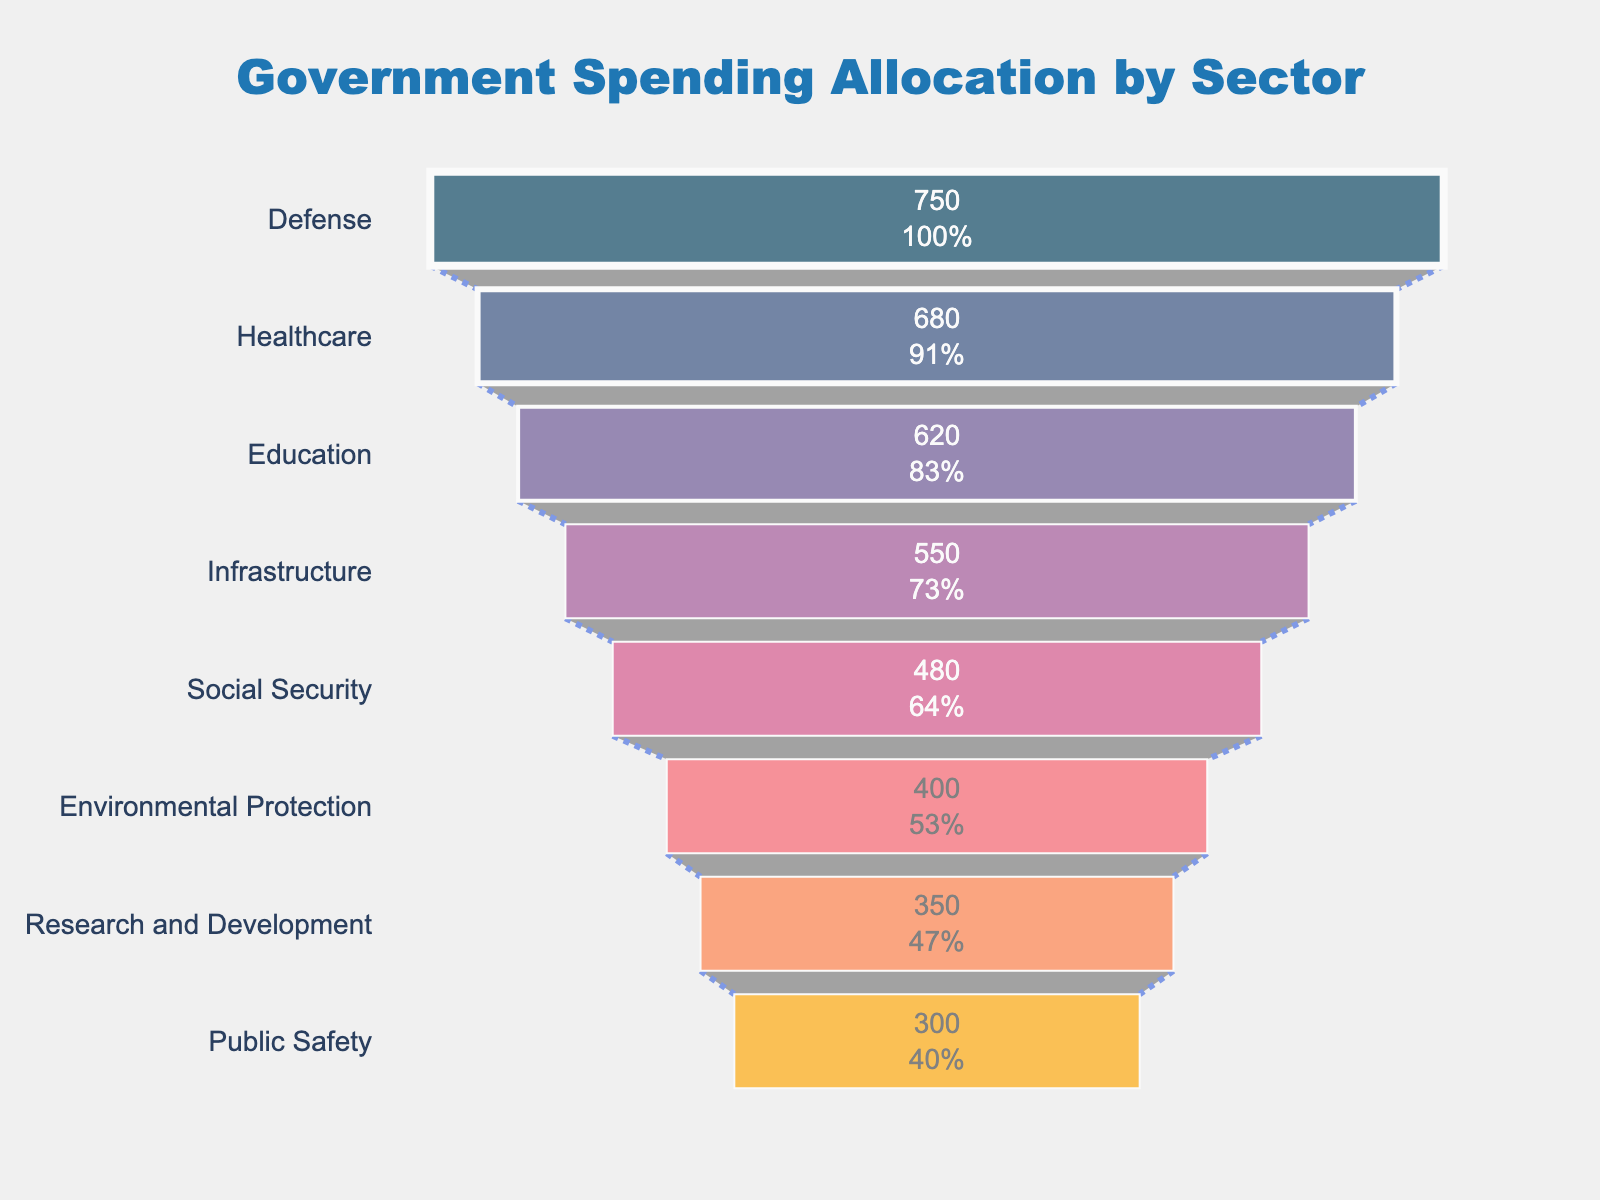What is the sector with the highest budget allocation? The chart shows the sectors in descending order of budget allocation. The first sector listed is Defense, which has the highest budget allocation.
Answer: Defense What is the total budget allocation for Infrastructure and Social Security combined? To find the total, add the budget allocation for Infrastructure (550 Billion USD) and Social Security (480 Billion USD). Therefore, 550 + 480 = 1030.
Answer: 1030 Billion USD Which sector has a lower budget allocation: Education or Healthcare? Compare the budget allocations of Education (620 Billion USD) and Healthcare (680 Billion USD). Education has a lower budget allocation than Healthcare.
Answer: Education How much more is allocated to Defense than to Research and Development? Subtract the budget allocation for Research and Development (350 Billion USD) from Defense (750 Billion USD). Therefore, 750 - 350 = 400.
Answer: 400 Billion USD What percentage of the initial budget allocation does Healthcare have? From the funnel chart, Healthcare is the second sector, and it is 680 Billion USD. The initial total budget (from Defense) is 750 Billion USD. So, (680 / 750) * 100 = 90.67%.
Answer: 90.67% What is the sum of the budget allocations for Environmental Protection, Public Safety, and Research and Development? Add the budget allocations for Environmental Protection (400 Billion USD), Public Safety (300 Billion USD), and Research and Development (350 Billion USD). Therefore, 400 + 300 + 350 = 1050.
Answer: 1050 Billion USD Which sector has the least budget allocation, and what is its value? The last sector listed in the descending order funnel chart is Public Safety, with a budget allocation of 300 Billion USD.
Answer: Public Safety, 300 Billion USD If you combine the budget allocations for Healthcare and Education, how does it compare to the budget allocation for Defense? The combined budget for Healthcare (680 Billion USD) and Education (620 Billion USD) is 680 + 620 = 1300 Billion USD, which is greater than Defense's 750 Billion USD.
Answer: The combined budget is greater than Defense How many sectors have a budget allocation of 500 Billion USD or more? Review the chart, and count the sectors with budget allocations equal to or more than 500 Billion USD: Defense (750), Healthcare (680), Education (620), and Infrastructure (550), resulting in 4 sectors.
Answer: 4 